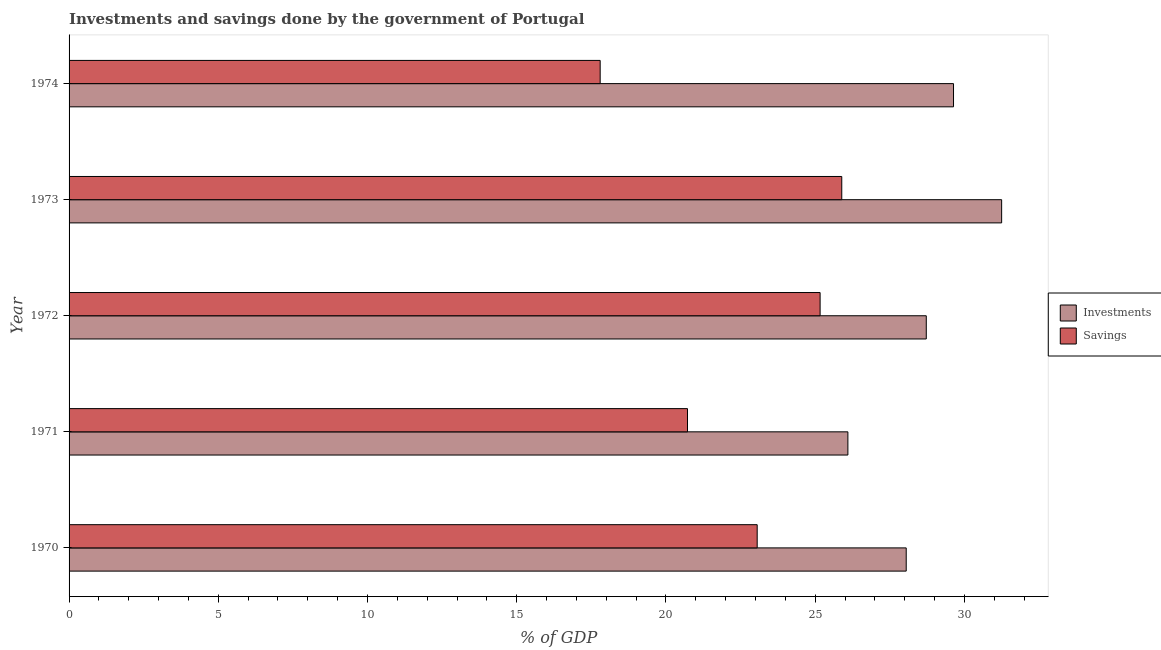How many bars are there on the 5th tick from the top?
Offer a very short reply. 2. What is the label of the 1st group of bars from the top?
Provide a short and direct response. 1974. In how many cases, is the number of bars for a given year not equal to the number of legend labels?
Give a very brief answer. 0. What is the savings of government in 1971?
Your answer should be compact. 20.72. Across all years, what is the maximum investments of government?
Your answer should be very brief. 31.25. Across all years, what is the minimum investments of government?
Your answer should be compact. 26.1. In which year was the investments of government maximum?
Offer a terse response. 1973. In which year was the savings of government minimum?
Your response must be concise. 1974. What is the total investments of government in the graph?
Provide a succinct answer. 143.75. What is the difference between the investments of government in 1972 and that in 1973?
Ensure brevity in your answer.  -2.52. What is the difference between the savings of government in 1973 and the investments of government in 1974?
Give a very brief answer. -3.74. What is the average savings of government per year?
Your answer should be very brief. 22.53. In the year 1973, what is the difference between the savings of government and investments of government?
Offer a very short reply. -5.36. What is the difference between the highest and the second highest savings of government?
Provide a short and direct response. 0.73. What is the difference between the highest and the lowest investments of government?
Ensure brevity in your answer.  5.15. What does the 1st bar from the top in 1974 represents?
Provide a short and direct response. Savings. What does the 1st bar from the bottom in 1974 represents?
Your response must be concise. Investments. Are all the bars in the graph horizontal?
Your answer should be compact. Yes. What is the difference between two consecutive major ticks on the X-axis?
Provide a succinct answer. 5. Does the graph contain any zero values?
Your response must be concise. No. Does the graph contain grids?
Keep it short and to the point. No. Where does the legend appear in the graph?
Offer a very short reply. Center right. What is the title of the graph?
Your answer should be very brief. Investments and savings done by the government of Portugal. Does "Arms imports" appear as one of the legend labels in the graph?
Give a very brief answer. No. What is the label or title of the X-axis?
Your response must be concise. % of GDP. What is the label or title of the Y-axis?
Ensure brevity in your answer.  Year. What is the % of GDP of Investments in 1970?
Offer a terse response. 28.05. What is the % of GDP of Savings in 1970?
Your response must be concise. 23.06. What is the % of GDP of Investments in 1971?
Your response must be concise. 26.1. What is the % of GDP in Savings in 1971?
Provide a succinct answer. 20.72. What is the % of GDP in Investments in 1972?
Make the answer very short. 28.72. What is the % of GDP in Savings in 1972?
Ensure brevity in your answer.  25.17. What is the % of GDP of Investments in 1973?
Ensure brevity in your answer.  31.25. What is the % of GDP in Savings in 1973?
Make the answer very short. 25.89. What is the % of GDP in Investments in 1974?
Give a very brief answer. 29.64. What is the % of GDP in Savings in 1974?
Offer a terse response. 17.8. Across all years, what is the maximum % of GDP in Investments?
Make the answer very short. 31.25. Across all years, what is the maximum % of GDP of Savings?
Your response must be concise. 25.89. Across all years, what is the minimum % of GDP of Investments?
Offer a very short reply. 26.1. Across all years, what is the minimum % of GDP in Savings?
Give a very brief answer. 17.8. What is the total % of GDP of Investments in the graph?
Your answer should be compact. 143.75. What is the total % of GDP in Savings in the graph?
Provide a succinct answer. 112.63. What is the difference between the % of GDP in Investments in 1970 and that in 1971?
Provide a short and direct response. 1.95. What is the difference between the % of GDP in Savings in 1970 and that in 1971?
Your answer should be compact. 2.33. What is the difference between the % of GDP in Investments in 1970 and that in 1972?
Make the answer very short. -0.67. What is the difference between the % of GDP of Savings in 1970 and that in 1972?
Provide a short and direct response. -2.11. What is the difference between the % of GDP of Investments in 1970 and that in 1973?
Offer a very short reply. -3.2. What is the difference between the % of GDP in Savings in 1970 and that in 1973?
Offer a terse response. -2.83. What is the difference between the % of GDP in Investments in 1970 and that in 1974?
Make the answer very short. -1.59. What is the difference between the % of GDP of Savings in 1970 and that in 1974?
Your answer should be compact. 5.26. What is the difference between the % of GDP of Investments in 1971 and that in 1972?
Your answer should be compact. -2.63. What is the difference between the % of GDP of Savings in 1971 and that in 1972?
Keep it short and to the point. -4.44. What is the difference between the % of GDP in Investments in 1971 and that in 1973?
Your answer should be very brief. -5.15. What is the difference between the % of GDP of Savings in 1971 and that in 1973?
Make the answer very short. -5.17. What is the difference between the % of GDP in Investments in 1971 and that in 1974?
Offer a very short reply. -3.54. What is the difference between the % of GDP in Savings in 1971 and that in 1974?
Keep it short and to the point. 2.93. What is the difference between the % of GDP in Investments in 1972 and that in 1973?
Your answer should be very brief. -2.53. What is the difference between the % of GDP of Savings in 1972 and that in 1973?
Offer a very short reply. -0.73. What is the difference between the % of GDP in Investments in 1972 and that in 1974?
Provide a short and direct response. -0.91. What is the difference between the % of GDP in Savings in 1972 and that in 1974?
Make the answer very short. 7.37. What is the difference between the % of GDP in Investments in 1973 and that in 1974?
Give a very brief answer. 1.61. What is the difference between the % of GDP of Savings in 1973 and that in 1974?
Offer a very short reply. 8.1. What is the difference between the % of GDP in Investments in 1970 and the % of GDP in Savings in 1971?
Provide a succinct answer. 7.33. What is the difference between the % of GDP in Investments in 1970 and the % of GDP in Savings in 1972?
Keep it short and to the point. 2.89. What is the difference between the % of GDP in Investments in 1970 and the % of GDP in Savings in 1973?
Provide a succinct answer. 2.16. What is the difference between the % of GDP in Investments in 1970 and the % of GDP in Savings in 1974?
Keep it short and to the point. 10.25. What is the difference between the % of GDP of Investments in 1971 and the % of GDP of Savings in 1972?
Offer a terse response. 0.93. What is the difference between the % of GDP in Investments in 1971 and the % of GDP in Savings in 1973?
Offer a terse response. 0.2. What is the difference between the % of GDP of Investments in 1971 and the % of GDP of Savings in 1974?
Offer a very short reply. 8.3. What is the difference between the % of GDP in Investments in 1972 and the % of GDP in Savings in 1973?
Keep it short and to the point. 2.83. What is the difference between the % of GDP in Investments in 1972 and the % of GDP in Savings in 1974?
Offer a terse response. 10.93. What is the difference between the % of GDP of Investments in 1973 and the % of GDP of Savings in 1974?
Provide a short and direct response. 13.45. What is the average % of GDP of Investments per year?
Your response must be concise. 28.75. What is the average % of GDP in Savings per year?
Your answer should be compact. 22.53. In the year 1970, what is the difference between the % of GDP in Investments and % of GDP in Savings?
Your answer should be compact. 4.99. In the year 1971, what is the difference between the % of GDP in Investments and % of GDP in Savings?
Your answer should be compact. 5.37. In the year 1972, what is the difference between the % of GDP in Investments and % of GDP in Savings?
Your response must be concise. 3.56. In the year 1973, what is the difference between the % of GDP in Investments and % of GDP in Savings?
Provide a succinct answer. 5.36. In the year 1974, what is the difference between the % of GDP in Investments and % of GDP in Savings?
Your response must be concise. 11.84. What is the ratio of the % of GDP of Investments in 1970 to that in 1971?
Your response must be concise. 1.07. What is the ratio of the % of GDP in Savings in 1970 to that in 1971?
Your response must be concise. 1.11. What is the ratio of the % of GDP in Investments in 1970 to that in 1972?
Give a very brief answer. 0.98. What is the ratio of the % of GDP in Savings in 1970 to that in 1972?
Provide a short and direct response. 0.92. What is the ratio of the % of GDP in Investments in 1970 to that in 1973?
Provide a succinct answer. 0.9. What is the ratio of the % of GDP in Savings in 1970 to that in 1973?
Your response must be concise. 0.89. What is the ratio of the % of GDP of Investments in 1970 to that in 1974?
Offer a very short reply. 0.95. What is the ratio of the % of GDP of Savings in 1970 to that in 1974?
Offer a very short reply. 1.3. What is the ratio of the % of GDP in Investments in 1971 to that in 1972?
Provide a succinct answer. 0.91. What is the ratio of the % of GDP of Savings in 1971 to that in 1972?
Your answer should be very brief. 0.82. What is the ratio of the % of GDP of Investments in 1971 to that in 1973?
Provide a succinct answer. 0.84. What is the ratio of the % of GDP of Savings in 1971 to that in 1973?
Provide a succinct answer. 0.8. What is the ratio of the % of GDP of Investments in 1971 to that in 1974?
Offer a terse response. 0.88. What is the ratio of the % of GDP of Savings in 1971 to that in 1974?
Keep it short and to the point. 1.16. What is the ratio of the % of GDP of Investments in 1972 to that in 1973?
Ensure brevity in your answer.  0.92. What is the ratio of the % of GDP in Investments in 1972 to that in 1974?
Ensure brevity in your answer.  0.97. What is the ratio of the % of GDP in Savings in 1972 to that in 1974?
Your answer should be very brief. 1.41. What is the ratio of the % of GDP of Investments in 1973 to that in 1974?
Your answer should be very brief. 1.05. What is the ratio of the % of GDP in Savings in 1973 to that in 1974?
Your response must be concise. 1.45. What is the difference between the highest and the second highest % of GDP of Investments?
Make the answer very short. 1.61. What is the difference between the highest and the second highest % of GDP of Savings?
Make the answer very short. 0.73. What is the difference between the highest and the lowest % of GDP in Investments?
Offer a terse response. 5.15. What is the difference between the highest and the lowest % of GDP in Savings?
Ensure brevity in your answer.  8.1. 